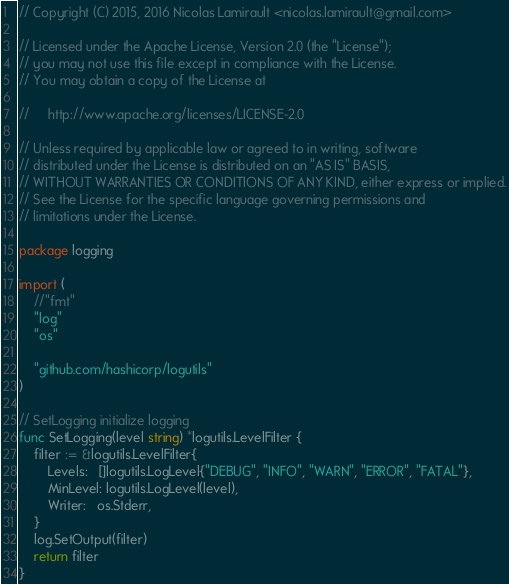Convert code to text. <code><loc_0><loc_0><loc_500><loc_500><_Go_>// Copyright (C) 2015, 2016 Nicolas Lamirault <nicolas.lamirault@gmail.com>

// Licensed under the Apache License, Version 2.0 (the "License");
// you may not use this file except in compliance with the License.
// You may obtain a copy of the License at

//     http://www.apache.org/licenses/LICENSE-2.0

// Unless required by applicable law or agreed to in writing, software
// distributed under the License is distributed on an "AS IS" BASIS,
// WITHOUT WARRANTIES OR CONDITIONS OF ANY KIND, either express or implied.
// See the License for the specific language governing permissions and
// limitations under the License.

package logging

import (
	//"fmt"
	"log"
	"os"

	"github.com/hashicorp/logutils"
)

// SetLogging initialize logging
func SetLogging(level string) *logutils.LevelFilter {
	filter := &logutils.LevelFilter{
		Levels:   []logutils.LogLevel{"DEBUG", "INFO", "WARN", "ERROR", "FATAL"},
		MinLevel: logutils.LogLevel(level),
		Writer:   os.Stderr,
	}
	log.SetOutput(filter)
	return filter
}
</code> 